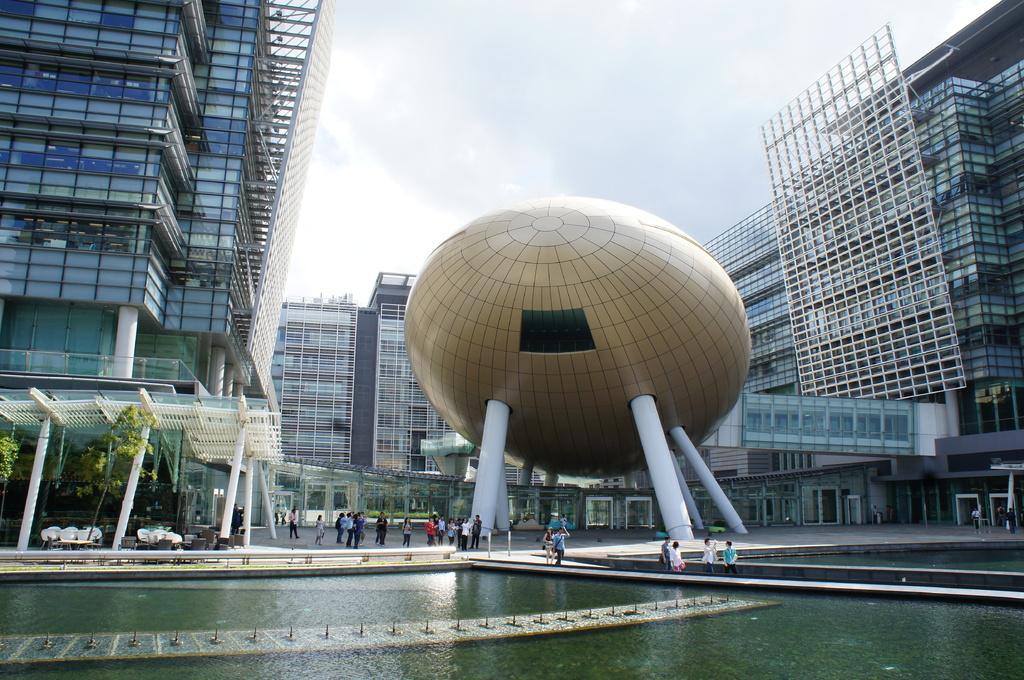What is the primary element visible in the image? There is water in the image. Are there any living beings present in the image? Yes, there are people in the image. What type of structures can be seen in the image? There are poles and buildings in the image. What type of vegetation is present in the image? There are trees in the image. Can you describe the shape of an object in the image? There is an object with a circular shape in the image. What is visible in the background of the image? The sky is visible in the background of the image. What type of knot is being tied by the elbow in the image? There is no elbow or knot present in the image. 